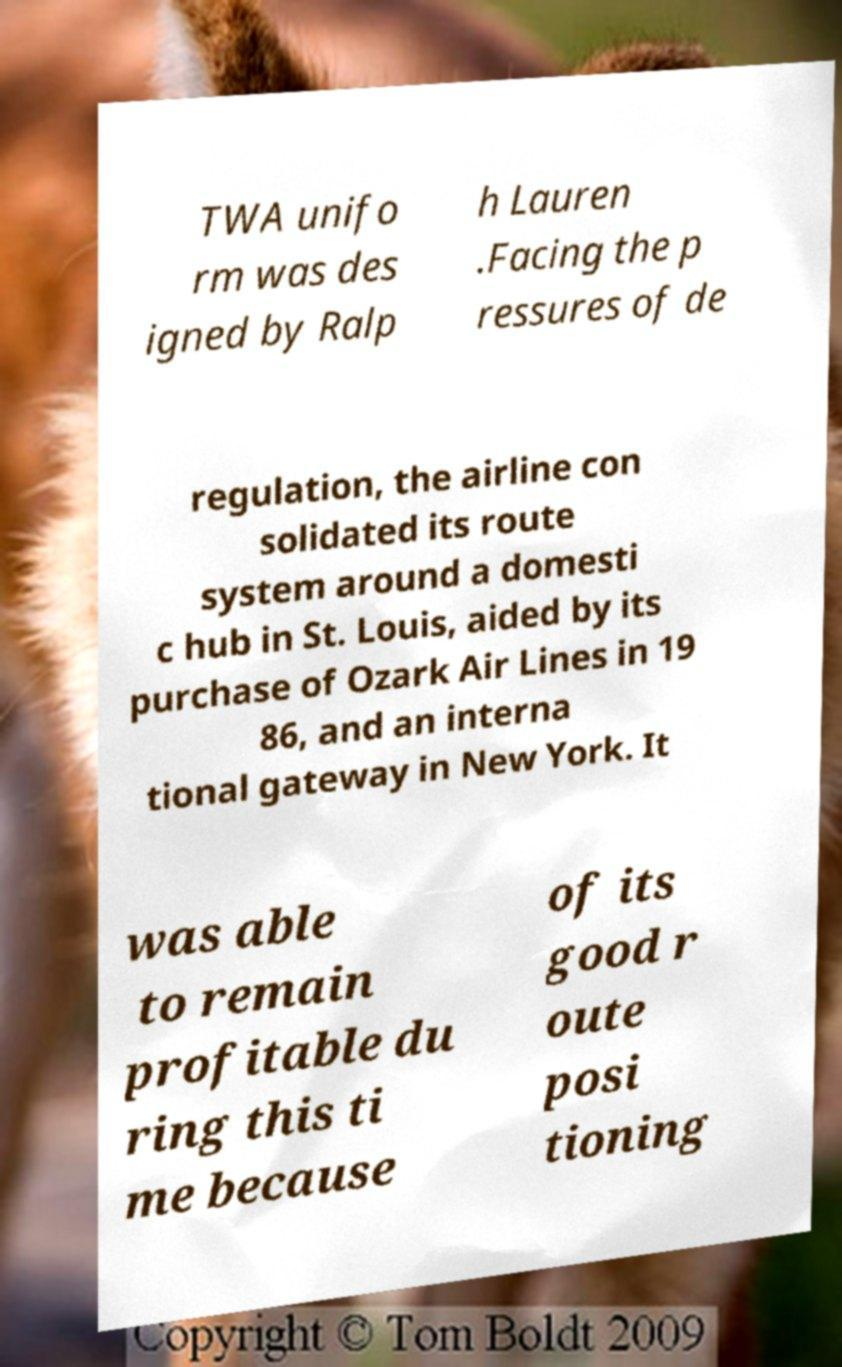Please read and relay the text visible in this image. What does it say? TWA unifo rm was des igned by Ralp h Lauren .Facing the p ressures of de regulation, the airline con solidated its route system around a domesti c hub in St. Louis, aided by its purchase of Ozark Air Lines in 19 86, and an interna tional gateway in New York. It was able to remain profitable du ring this ti me because of its good r oute posi tioning 